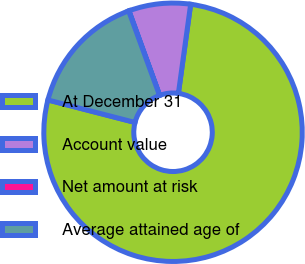Convert chart. <chart><loc_0><loc_0><loc_500><loc_500><pie_chart><fcel>At December 31<fcel>Account value<fcel>Net amount at risk<fcel>Average attained age of<nl><fcel>76.84%<fcel>7.72%<fcel>0.04%<fcel>15.4%<nl></chart> 